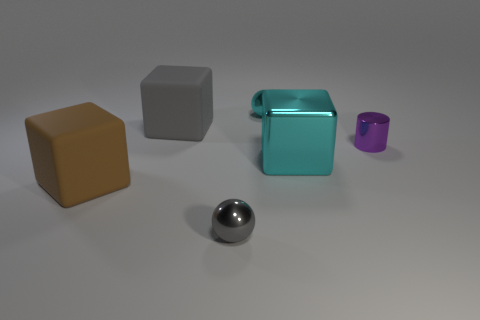Is the shape of the gray object in front of the large brown matte block the same as the large rubber object that is on the right side of the big brown thing? The gray object in front appears to be a cube, and its shape is not the same as the large rubber object to the right of the brown block, which also seems to be a cube but with a different texture and possibly slight size difference. Without being able to manipulate the objects or view them from multiple angles, a definitive comparison is limited to these observable characteristics. 